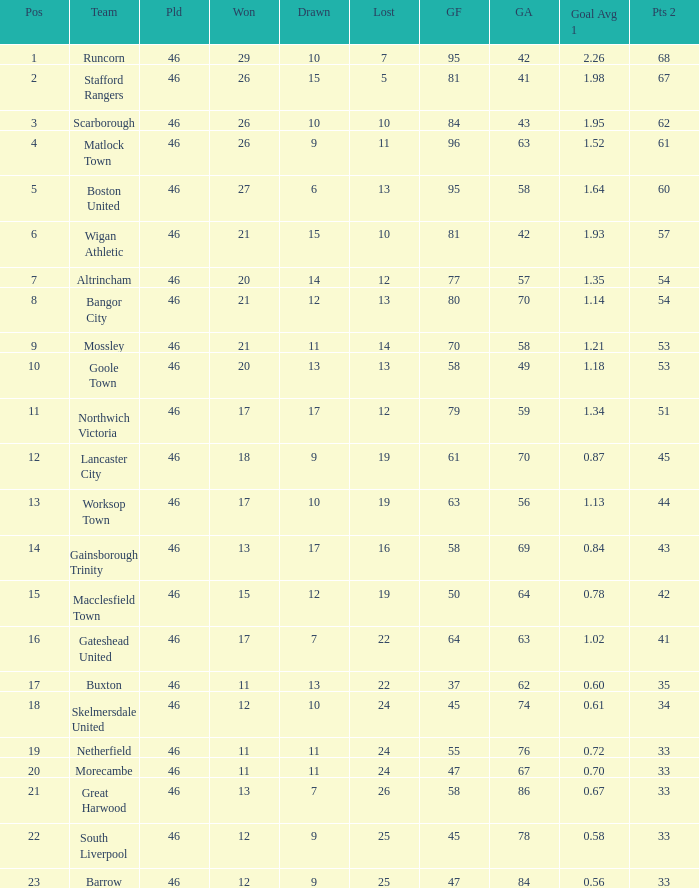How many times did the Lancaster City team play? 1.0. 